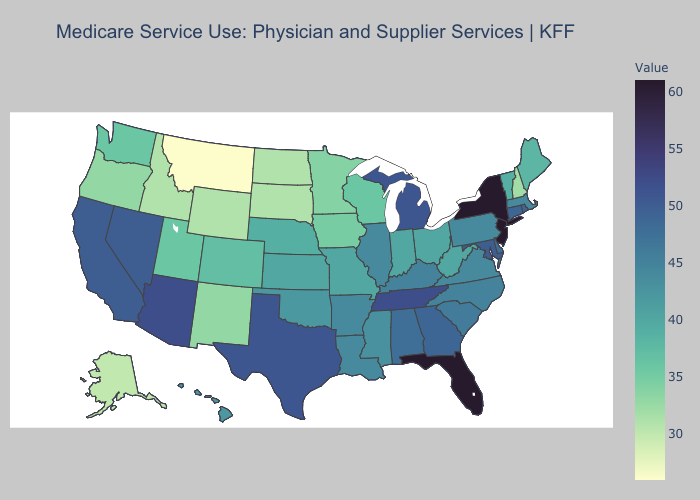Among the states that border Connecticut , does Rhode Island have the lowest value?
Answer briefly. No. Does Montana have the lowest value in the USA?
Quick response, please. Yes. Does the map have missing data?
Answer briefly. No. Does Wyoming have a higher value than Montana?
Answer briefly. Yes. Which states have the lowest value in the USA?
Answer briefly. Montana. Among the states that border Iowa , which have the lowest value?
Give a very brief answer. South Dakota. Among the states that border West Virginia , which have the lowest value?
Keep it brief. Ohio. 